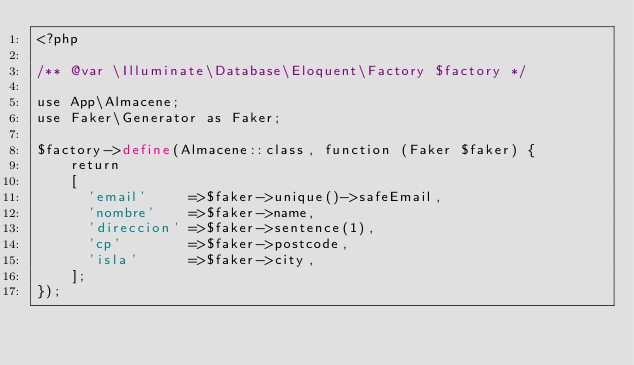Convert code to text. <code><loc_0><loc_0><loc_500><loc_500><_PHP_><?php

/** @var \Illuminate\Database\Eloquent\Factory $factory */

use App\Almacene;
use Faker\Generator as Faker;

$factory->define(Almacene::class, function (Faker $faker) {
    return
    [ 
      'email'     =>$faker->unique()->safeEmail,
      'nombre'    =>$faker->name,
      'direccion' =>$faker->sentence(1),
      'cp'        =>$faker->postcode,
      'isla'      =>$faker->city,
    ];
});
</code> 